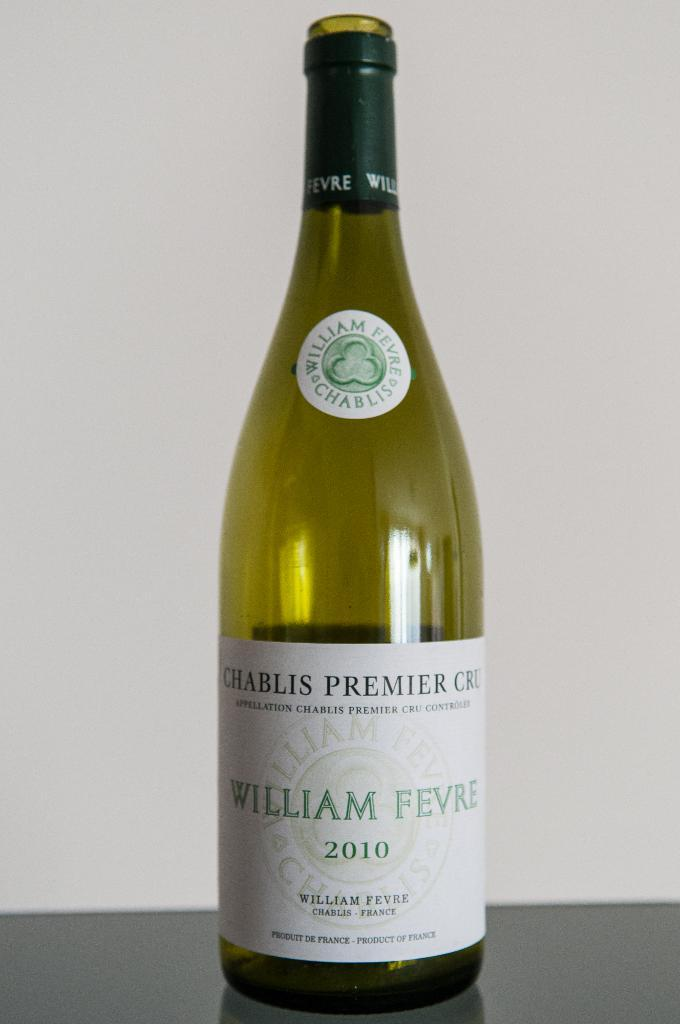What object is featured in the picture? There is a bottle in the picture. How is the bottle emphasized in the image? The bottle is highlighted. Is there any additional information about the bottle? Yes, there is a sticker on the bottle. Can you tell me how many basketballs are visible in the picture? There are no basketballs present in the image; it features a bottle with a sticker. What type of duck is sitting on top of the bottle in the picture? There is no duck present in the image; it features a bottle with a sticker. 